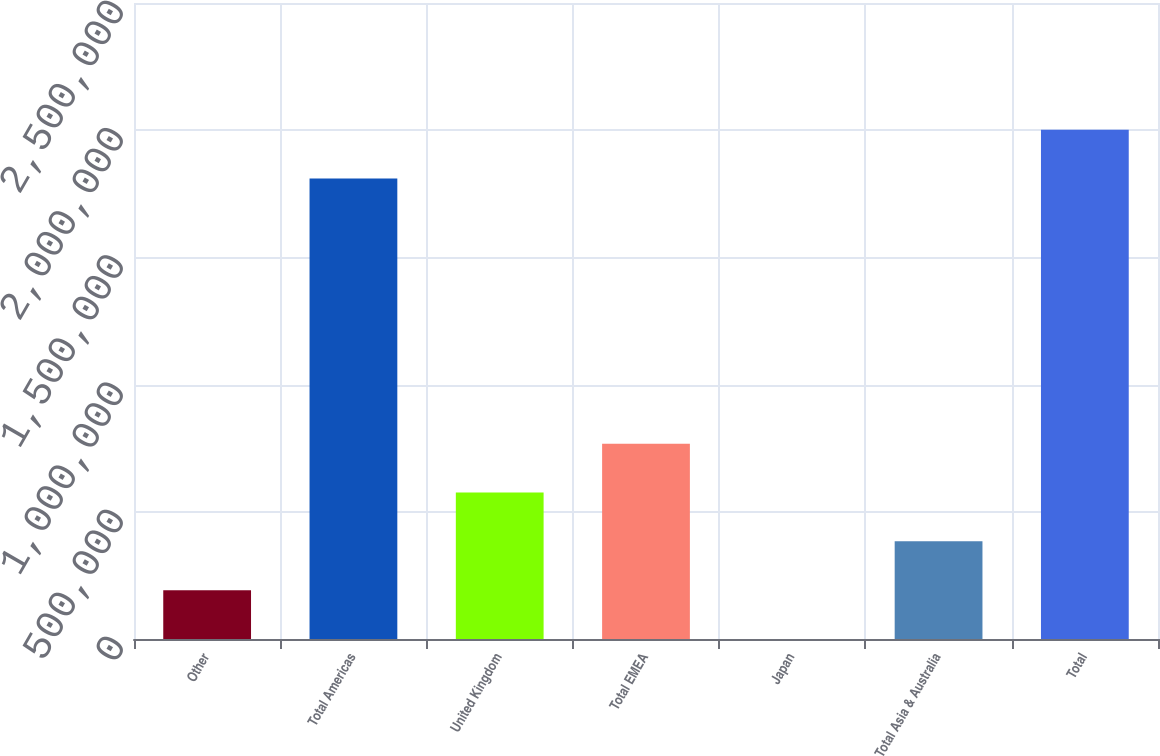Convert chart. <chart><loc_0><loc_0><loc_500><loc_500><bar_chart><fcel>Other<fcel>Total Americas<fcel>United Kingdom<fcel>Total EMEA<fcel>Japan<fcel>Total Asia & Australia<fcel>Total<nl><fcel>192114<fcel>1.80988e+06<fcel>575520<fcel>767223<fcel>411<fcel>383817<fcel>2.00158e+06<nl></chart> 